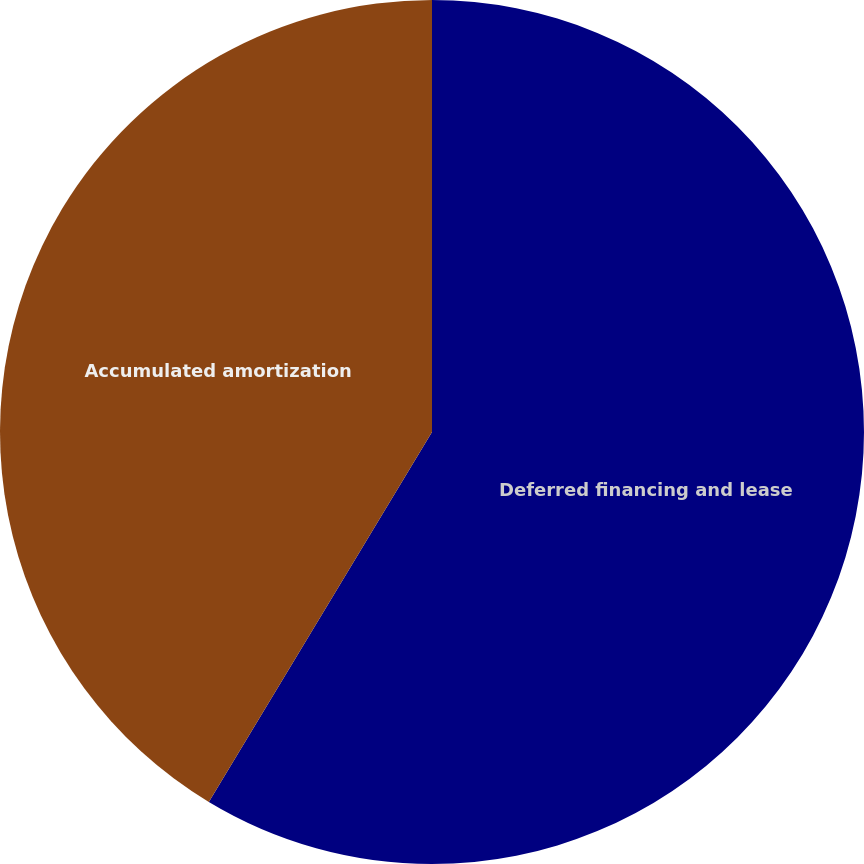Convert chart. <chart><loc_0><loc_0><loc_500><loc_500><pie_chart><fcel>Deferred financing and lease<fcel>Accumulated amortization<nl><fcel>58.64%<fcel>41.36%<nl></chart> 